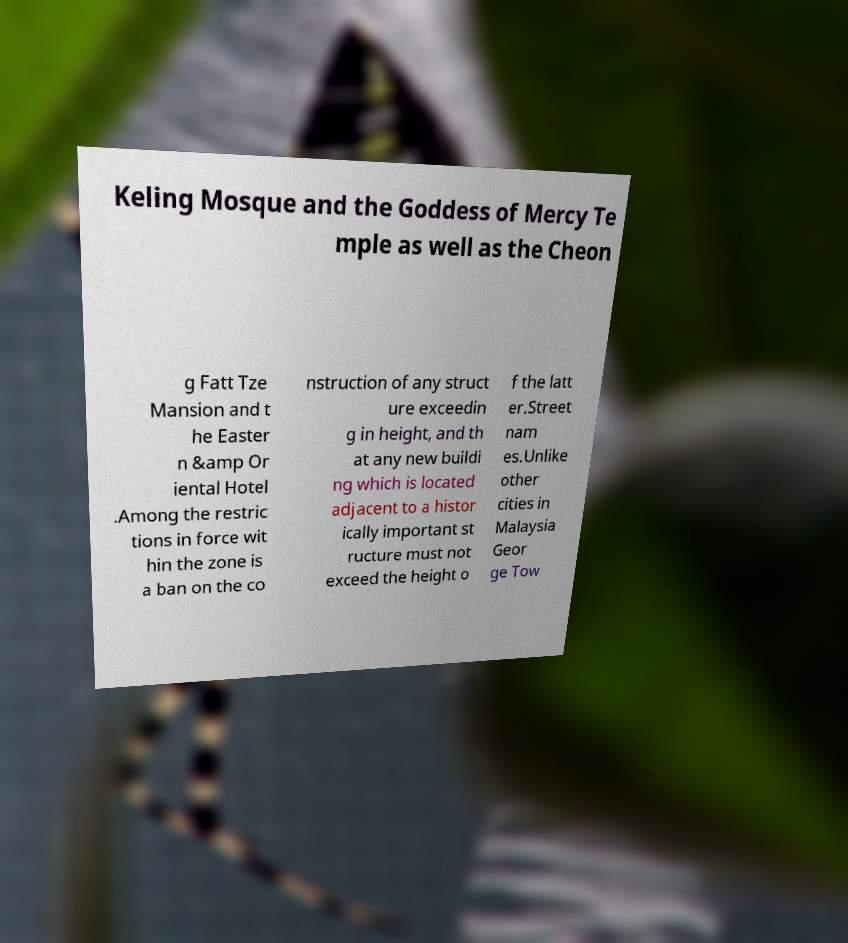Could you extract and type out the text from this image? Keling Mosque and the Goddess of Mercy Te mple as well as the Cheon g Fatt Tze Mansion and t he Easter n &amp Or iental Hotel .Among the restric tions in force wit hin the zone is a ban on the co nstruction of any struct ure exceedin g in height, and th at any new buildi ng which is located adjacent to a histor ically important st ructure must not exceed the height o f the latt er.Street nam es.Unlike other cities in Malaysia Geor ge Tow 